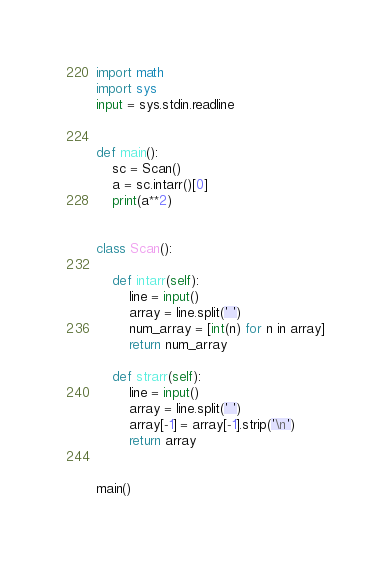Convert code to text. <code><loc_0><loc_0><loc_500><loc_500><_Python_>import math
import sys
input = sys.stdin.readline


def main():
    sc = Scan()
    a = sc.intarr()[0]
    print(a**2)


class Scan():

    def intarr(self):
        line = input()
        array = line.split(' ')
        num_array = [int(n) for n in array]
        return num_array

    def strarr(self):
        line = input()
        array = line.split(' ')
        array[-1] = array[-1].strip('\n')
        return array


main()
</code> 